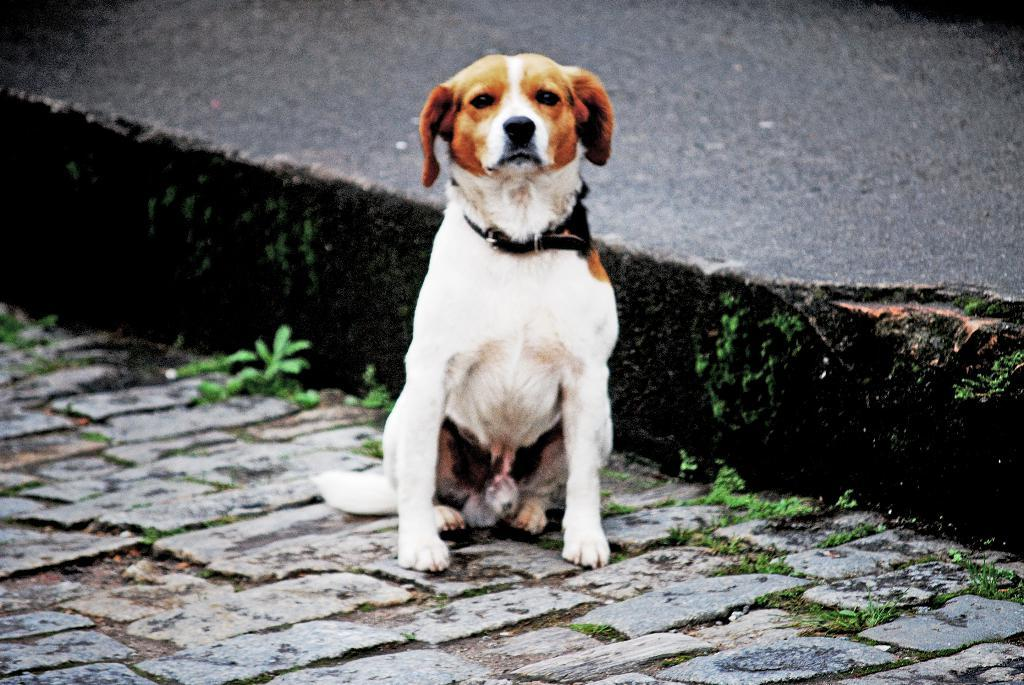What type of animal is in the image? There is a dog in the image. Where is the dog located? The dog is on the ground. What is the dog wearing? The dog has a belt on it. What can be seen in the background of the image? There is grass visible in the background of the image. Can you see an airplane flying through the sky in the image? No, there is no airplane visible in the image. 